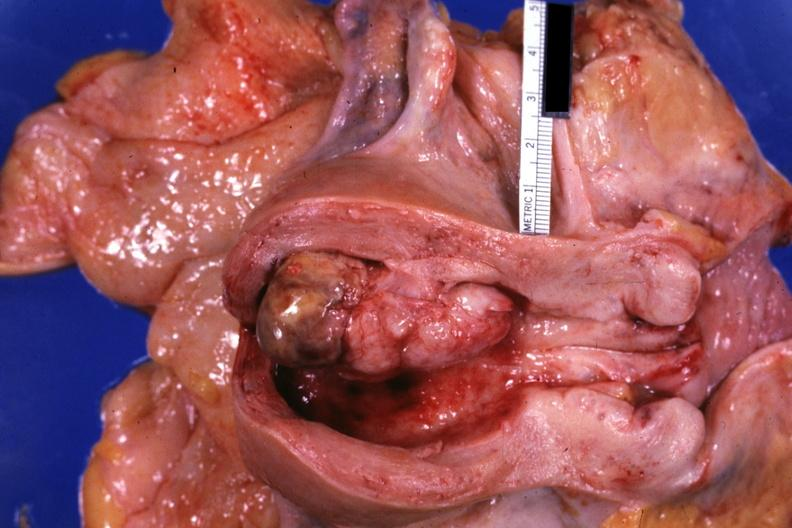s myocardial infarct present?
Answer the question using a single word or phrase. No 